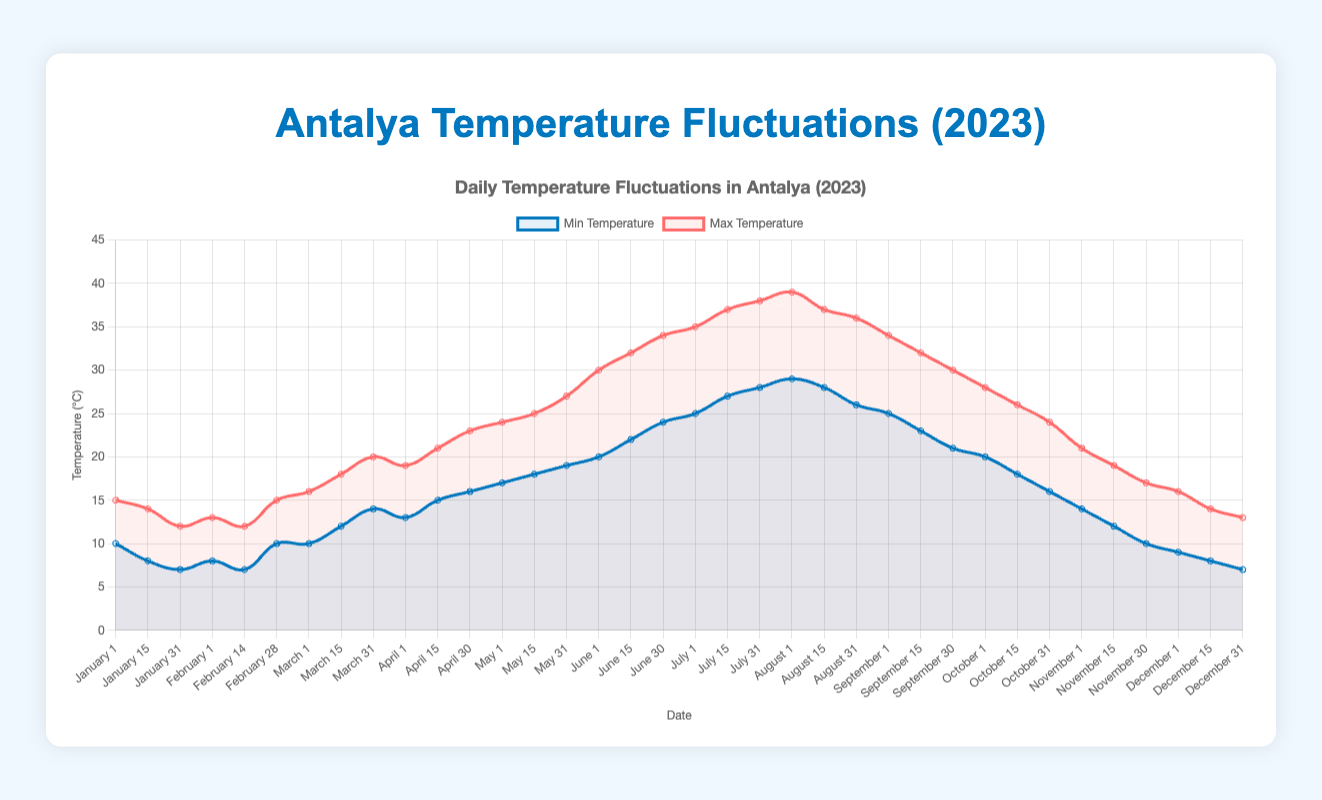What is the highest maximum temperature recorded in Antalya in 2023? By looking at the 'Max Temperature' dataset in the figure, the highest peak indicates the highest temperature, which is 39°C recorded in August.
Answer: 39°C What is the lowest minimum temperature recorded in Antalya in 2023? By observing the 'Min Temperature' dataset in the figure, the lowest dip represents the lowest temperature, which is 7°C recorded in January and December.
Answer: 7°C Does the maximum temperature ever reach below 15°C? Check the 'Max Temperature' dataset for values below the threshold. The plot shows that the maximum temperature is below 15°C in January and February.
Answer: Yes In which month does Antalya experience the largest temperature range between the minimum and maximum temperature? Comparing the differences between maximum and minimum temperatures for each month. The largest range is in August (39°C - 26°C = 13°C).
Answer: August What is the average minimum temperature in January? Sum the minimum temperatures in January (10 + 8 + 7) and divide by the number of days recorded (3). Average = (10 + 8 + 7) / 3 = 8.33°C.
Answer: 8.33°C In which month does the temperature begin to rise significantly after winter? From the plots, a significant rise in both minimum and maximum temperatures after winter is noticeable in March.
Answer: March Are there any months where the minimum temperature is consistently rising? By looking at the trend of 'Min Temperature' data points, a consistent rise is seen from March to August.
Answer: Yes Which month shows the least variation in temperature fluctuation? Examine the plot for the month where the gap between max and min temperatures is smallest. This occurs in January and February (close fluctuations between max and min temperatures).
Answer: January/February How does the maximum temperature in July compare to the maximum temperature in June? Comparing the peaks for June and July, July has a higher maximum temperature (38°C compared to June's 34°C).
Answer: July's maximum is higher What is the temperature range in June? The difference between the maximum and minimum temperatures in June (30°C - 20°C, 32°C - 22°C, 34°C - 24°C) averaging them yields ~12°C.
Answer: Roughly 12°C 